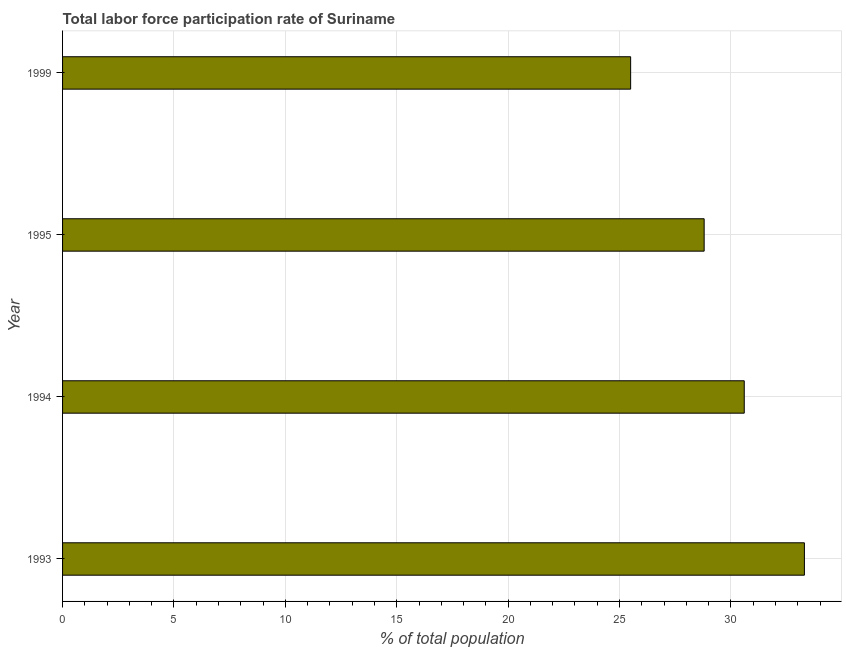What is the title of the graph?
Provide a short and direct response. Total labor force participation rate of Suriname. What is the label or title of the X-axis?
Keep it short and to the point. % of total population. What is the total labor force participation rate in 1993?
Provide a succinct answer. 33.3. Across all years, what is the maximum total labor force participation rate?
Keep it short and to the point. 33.3. In which year was the total labor force participation rate maximum?
Make the answer very short. 1993. In which year was the total labor force participation rate minimum?
Give a very brief answer. 1999. What is the sum of the total labor force participation rate?
Your response must be concise. 118.2. What is the difference between the total labor force participation rate in 1993 and 1999?
Offer a very short reply. 7.8. What is the average total labor force participation rate per year?
Offer a very short reply. 29.55. What is the median total labor force participation rate?
Make the answer very short. 29.7. Do a majority of the years between 1999 and 1995 (inclusive) have total labor force participation rate greater than 21 %?
Provide a short and direct response. No. What is the ratio of the total labor force participation rate in 1995 to that in 1999?
Ensure brevity in your answer.  1.13. Is the total labor force participation rate in 1993 less than that in 1995?
Offer a very short reply. No. Is the difference between the total labor force participation rate in 1995 and 1999 greater than the difference between any two years?
Give a very brief answer. No. Is the sum of the total labor force participation rate in 1994 and 1995 greater than the maximum total labor force participation rate across all years?
Your response must be concise. Yes. What is the difference between the highest and the lowest total labor force participation rate?
Give a very brief answer. 7.8. How many bars are there?
Your answer should be very brief. 4. Are all the bars in the graph horizontal?
Your response must be concise. Yes. What is the difference between two consecutive major ticks on the X-axis?
Your answer should be compact. 5. What is the % of total population of 1993?
Provide a succinct answer. 33.3. What is the % of total population in 1994?
Your response must be concise. 30.6. What is the % of total population of 1995?
Offer a terse response. 28.8. What is the difference between the % of total population in 1993 and 1994?
Your answer should be compact. 2.7. What is the difference between the % of total population in 1993 and 1999?
Offer a terse response. 7.8. What is the difference between the % of total population in 1994 and 1995?
Provide a short and direct response. 1.8. What is the difference between the % of total population in 1994 and 1999?
Provide a short and direct response. 5.1. What is the difference between the % of total population in 1995 and 1999?
Offer a terse response. 3.3. What is the ratio of the % of total population in 1993 to that in 1994?
Offer a very short reply. 1.09. What is the ratio of the % of total population in 1993 to that in 1995?
Keep it short and to the point. 1.16. What is the ratio of the % of total population in 1993 to that in 1999?
Your response must be concise. 1.31. What is the ratio of the % of total population in 1994 to that in 1995?
Keep it short and to the point. 1.06. What is the ratio of the % of total population in 1995 to that in 1999?
Keep it short and to the point. 1.13. 